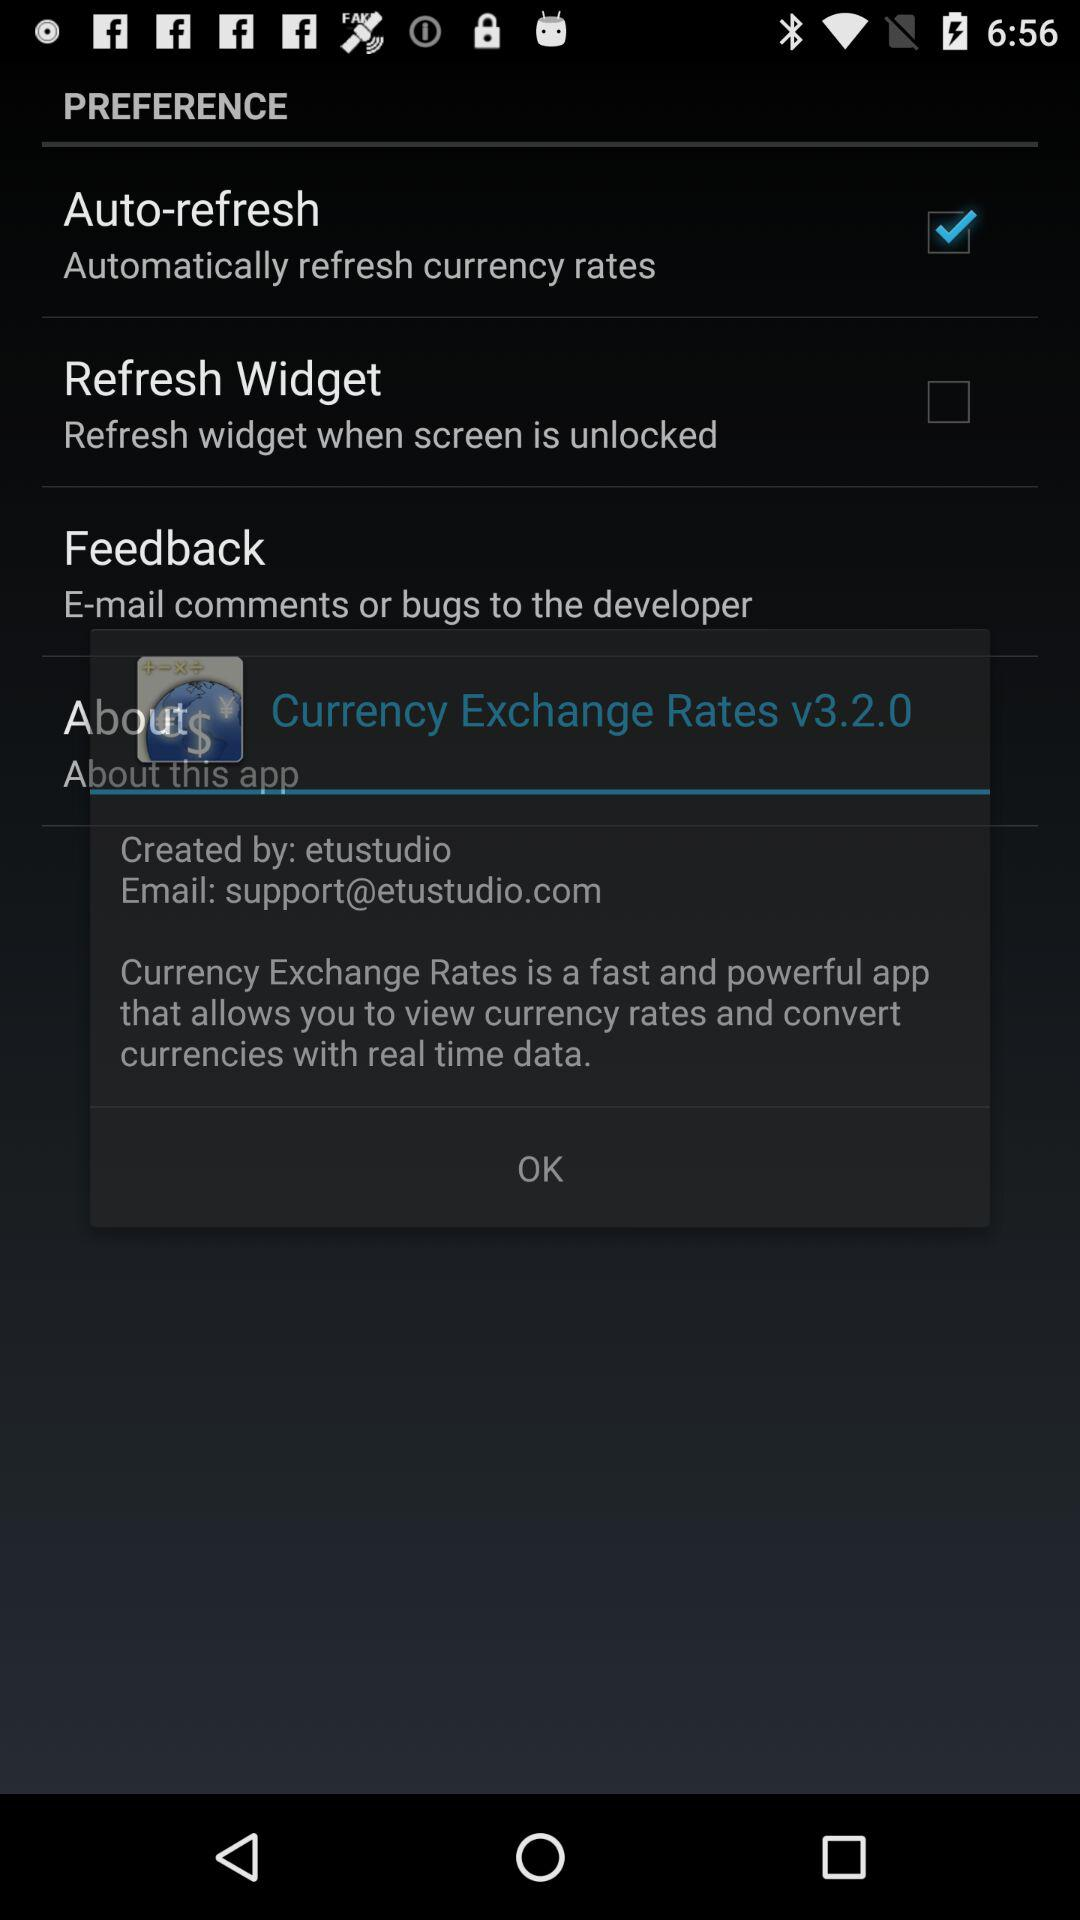Which tab is selected? The selected tab is "Trend". 